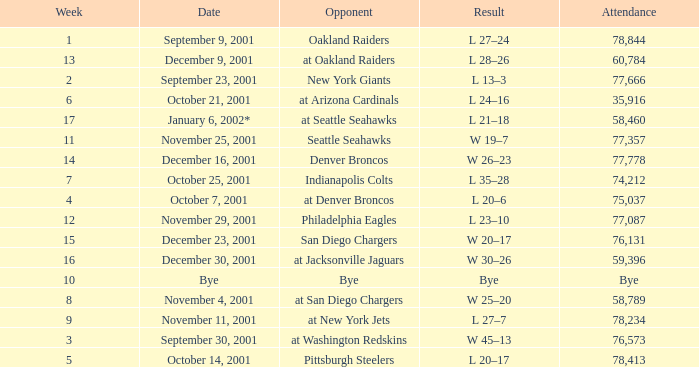How many attended the game on December 16, 2001? 77778.0. 